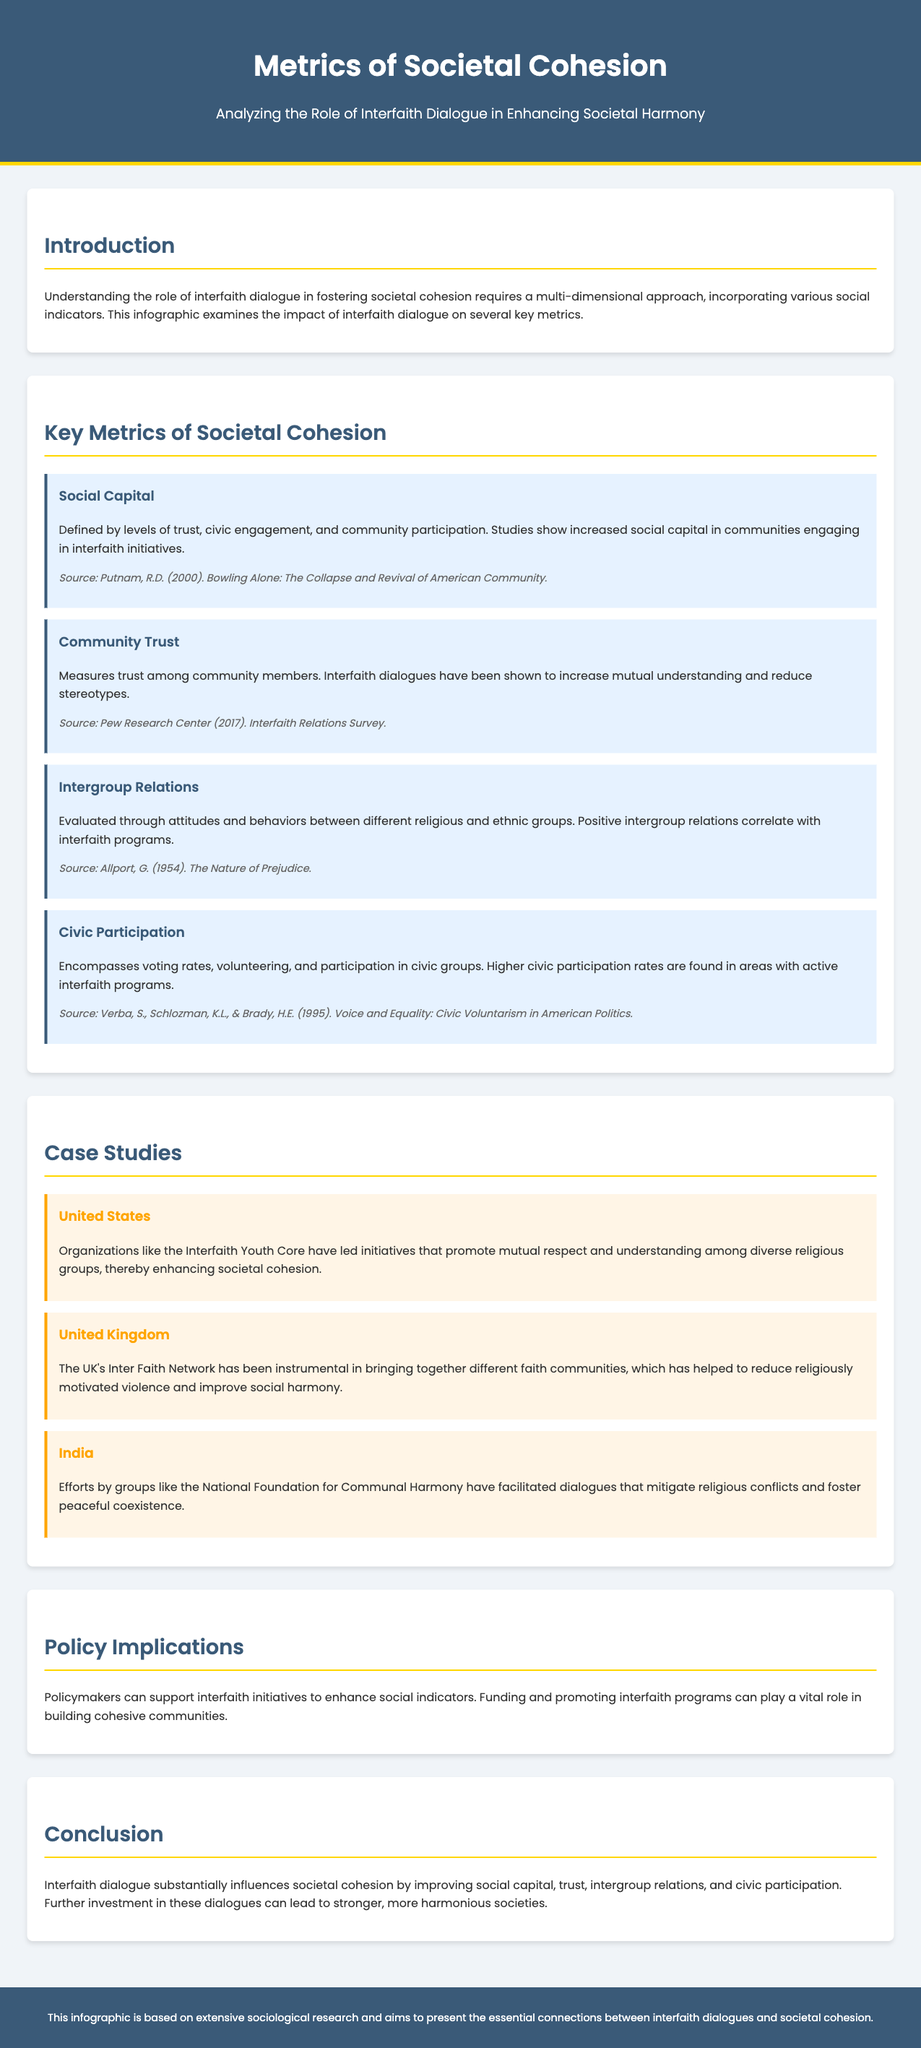what is the title of the infographic? The title of the infographic is stated prominently at the top of the document.
Answer: Metrics of Societal Cohesion: Interfaith Dialogue Impact who conducted the Interfaith Relations Survey? The source of the Community Trust metric cites the organization responsible for the survey.
Answer: Pew Research Center which country is mentioned first in the case studies section? The order of the case studies follows the mention of each nation, starting with the first listed.
Answer: United States what are the key metrics discussed in the document? The document includes a section detailing specific metrics, which are provided in a list format.
Answer: Social Capital, Community Trust, Intergroup Relations, Civic Participation what is one effect of interfaith dialogue on community trust? The document specifies a change in attitudes due to interfaith dialogue within a particular metric.
Answer: Increased mutual understanding and reduced stereotypes which organization in the United States promotes interfaith initiatives? The case study for the United States specifies an organization leading interfaith work.
Answer: Interfaith Youth Core what is a proposed policy implication mentioned in the document? The section on policy implications suggests a specific action that can be taken to promote societal cohesion.
Answer: Funding and promoting interfaith programs how does interfaith dialogue influence civic participation? The document outlines a measurable impact of interfaith dialogue on a specific social indicator.
Answer: Higher civic participation rates 